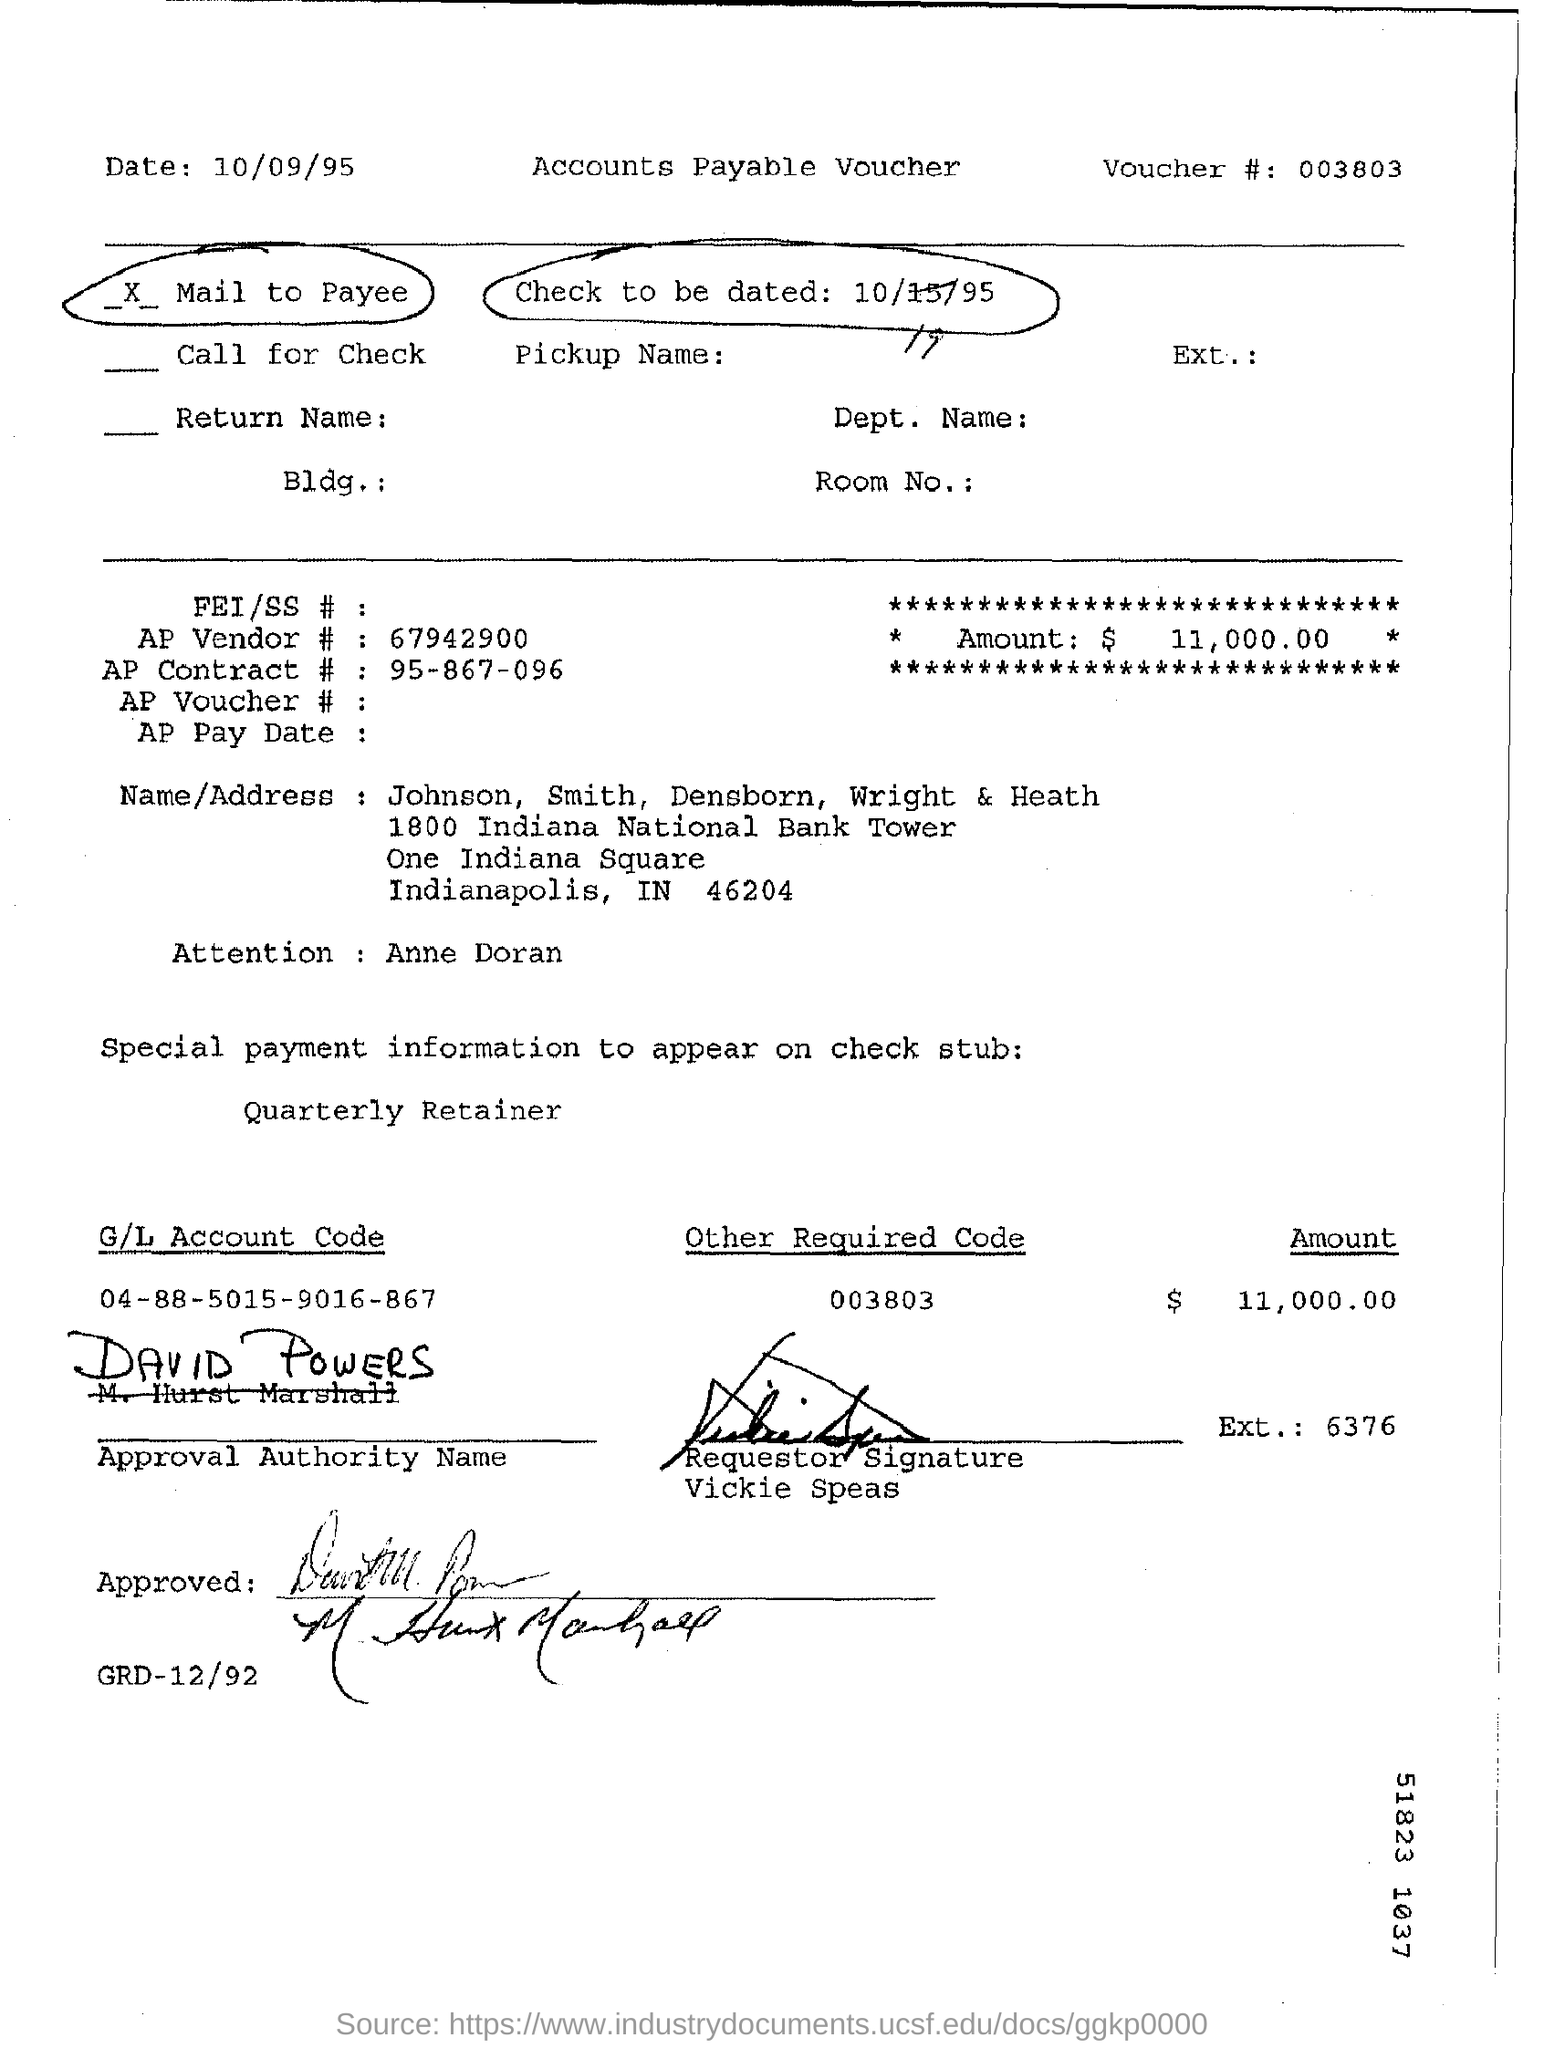Give some essential details in this illustration. David Powers is the approval authority. The AP Vendor number is 67942900. The amount is $11,000.00. The voucher number is 003803... 